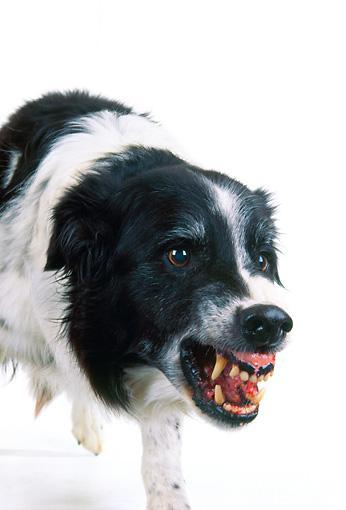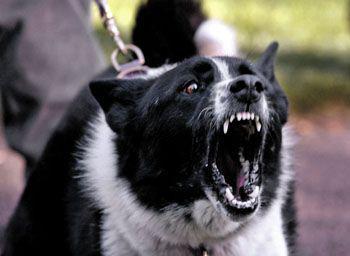The first image is the image on the left, the second image is the image on the right. For the images displayed, is the sentence "Both dogs are barring their teeth in aggression." factually correct? Answer yes or no. Yes. The first image is the image on the left, the second image is the image on the right. Evaluate the accuracy of this statement regarding the images: "Each image shows an angry-looking dog baring its fangs, and the dogs in the images face the same general direction.". Is it true? Answer yes or no. Yes. 